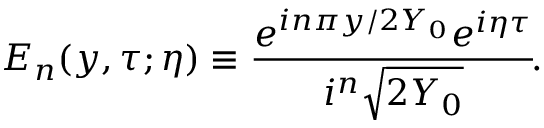Convert formula to latex. <formula><loc_0><loc_0><loc_500><loc_500>E _ { n } ( y , \tau ; \eta ) \equiv \frac { e ^ { i n \pi y / 2 Y _ { 0 } } e ^ { i \eta \tau } } { i ^ { n } \sqrt { 2 Y _ { 0 } } } \, .</formula> 